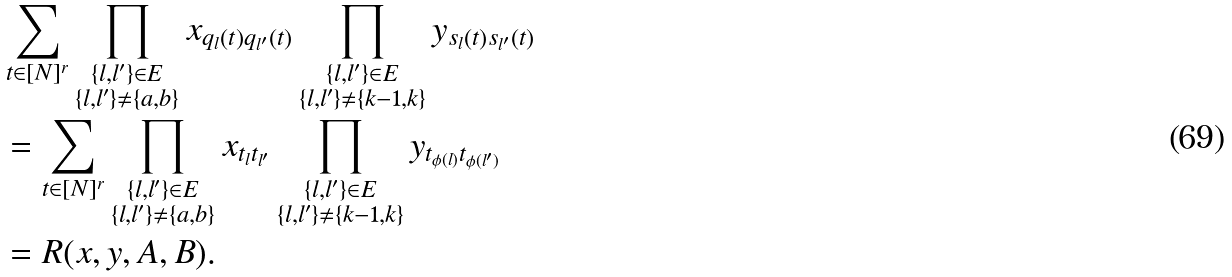<formula> <loc_0><loc_0><loc_500><loc_500>& \sum _ { t \in [ N ] ^ { r } } \prod _ { \substack { \{ l , l ^ { \prime } \} \in E \\ \{ l , l ^ { \prime } \} \ne \{ a , b \} } } x _ { q _ { l } ( t ) q _ { l ^ { \prime } } ( t ) } \prod _ { \substack { \{ l , l ^ { \prime } \} \in E \\ \{ l , l ^ { \prime } \} \ne \{ k - 1 , k \} } } y _ { s _ { l } ( t ) s _ { l ^ { \prime } } ( t ) } \\ & = \sum _ { t \in [ N ] ^ { r } } \prod _ { \substack { \{ l , l ^ { \prime } \} \in E \\ \{ l , l ^ { \prime } \} \ne \{ a , b \} } } x _ { t _ { l } t _ { l ^ { \prime } } } \prod _ { \substack { \{ l , l ^ { \prime } \} \in E \\ \{ l , l ^ { \prime } \} \ne \{ k - 1 , k \} } } y _ { t _ { \phi ( l ) } t _ { \phi ( l ^ { \prime } ) } } \\ & = R ( x , y , A , B ) .</formula> 